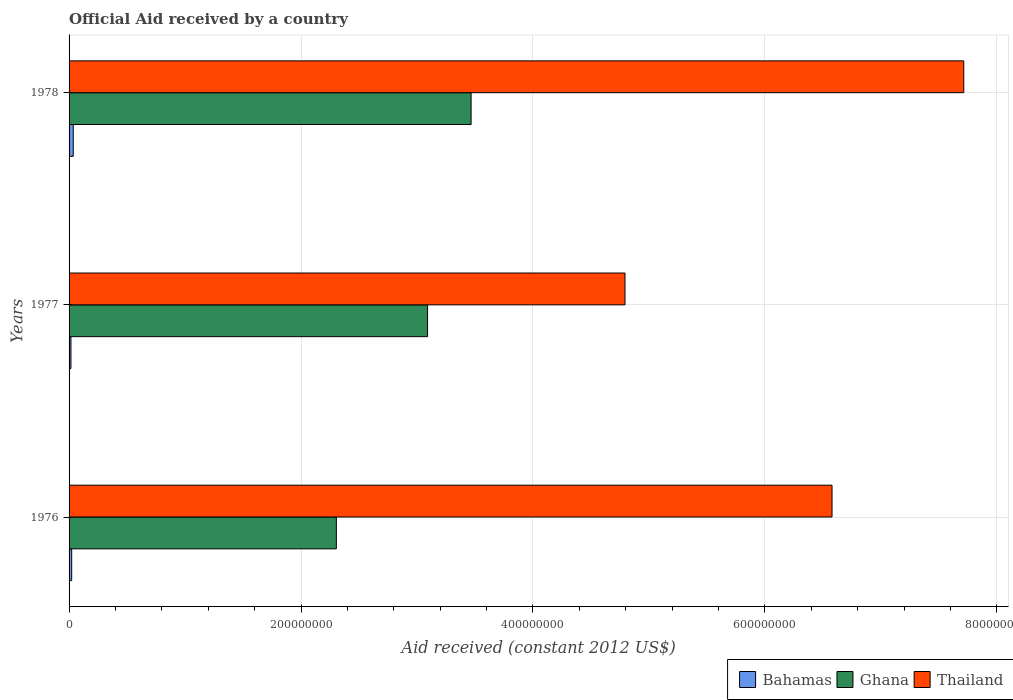How many groups of bars are there?
Ensure brevity in your answer.  3. Are the number of bars on each tick of the Y-axis equal?
Make the answer very short. Yes. In how many cases, is the number of bars for a given year not equal to the number of legend labels?
Offer a very short reply. 0. What is the net official aid received in Thailand in 1978?
Your answer should be compact. 7.71e+08. Across all years, what is the maximum net official aid received in Thailand?
Provide a short and direct response. 7.71e+08. Across all years, what is the minimum net official aid received in Thailand?
Ensure brevity in your answer.  4.79e+08. In which year was the net official aid received in Ghana maximum?
Offer a very short reply. 1978. In which year was the net official aid received in Thailand minimum?
Provide a succinct answer. 1977. What is the total net official aid received in Ghana in the graph?
Your answer should be very brief. 8.86e+08. What is the difference between the net official aid received in Bahamas in 1976 and that in 1978?
Provide a short and direct response. -1.35e+06. What is the difference between the net official aid received in Bahamas in 1978 and the net official aid received in Thailand in 1977?
Provide a short and direct response. -4.76e+08. What is the average net official aid received in Thailand per year?
Your response must be concise. 6.36e+08. In the year 1978, what is the difference between the net official aid received in Ghana and net official aid received in Thailand?
Ensure brevity in your answer.  -4.25e+08. What is the ratio of the net official aid received in Bahamas in 1977 to that in 1978?
Offer a very short reply. 0.45. Is the difference between the net official aid received in Ghana in 1976 and 1978 greater than the difference between the net official aid received in Thailand in 1976 and 1978?
Offer a terse response. No. What is the difference between the highest and the second highest net official aid received in Thailand?
Make the answer very short. 1.14e+08. What is the difference between the highest and the lowest net official aid received in Thailand?
Your answer should be compact. 2.92e+08. In how many years, is the net official aid received in Ghana greater than the average net official aid received in Ghana taken over all years?
Offer a very short reply. 2. Is the sum of the net official aid received in Thailand in 1977 and 1978 greater than the maximum net official aid received in Ghana across all years?
Ensure brevity in your answer.  Yes. What does the 1st bar from the top in 1978 represents?
Give a very brief answer. Thailand. What does the 3rd bar from the bottom in 1976 represents?
Provide a short and direct response. Thailand. Is it the case that in every year, the sum of the net official aid received in Bahamas and net official aid received in Ghana is greater than the net official aid received in Thailand?
Provide a succinct answer. No. How many years are there in the graph?
Offer a very short reply. 3. What is the difference between two consecutive major ticks on the X-axis?
Make the answer very short. 2.00e+08. Does the graph contain any zero values?
Offer a terse response. No. How many legend labels are there?
Make the answer very short. 3. What is the title of the graph?
Your response must be concise. Official Aid received by a country. Does "Solomon Islands" appear as one of the legend labels in the graph?
Make the answer very short. No. What is the label or title of the X-axis?
Your answer should be very brief. Aid received (constant 2012 US$). What is the Aid received (constant 2012 US$) of Bahamas in 1976?
Give a very brief answer. 2.25e+06. What is the Aid received (constant 2012 US$) in Ghana in 1976?
Your answer should be very brief. 2.30e+08. What is the Aid received (constant 2012 US$) of Thailand in 1976?
Provide a succinct answer. 6.58e+08. What is the Aid received (constant 2012 US$) of Bahamas in 1977?
Give a very brief answer. 1.62e+06. What is the Aid received (constant 2012 US$) of Ghana in 1977?
Your answer should be compact. 3.09e+08. What is the Aid received (constant 2012 US$) in Thailand in 1977?
Keep it short and to the point. 4.79e+08. What is the Aid received (constant 2012 US$) of Bahamas in 1978?
Offer a very short reply. 3.60e+06. What is the Aid received (constant 2012 US$) in Ghana in 1978?
Give a very brief answer. 3.47e+08. What is the Aid received (constant 2012 US$) of Thailand in 1978?
Give a very brief answer. 7.71e+08. Across all years, what is the maximum Aid received (constant 2012 US$) of Bahamas?
Provide a succinct answer. 3.60e+06. Across all years, what is the maximum Aid received (constant 2012 US$) in Ghana?
Your answer should be compact. 3.47e+08. Across all years, what is the maximum Aid received (constant 2012 US$) in Thailand?
Make the answer very short. 7.71e+08. Across all years, what is the minimum Aid received (constant 2012 US$) of Bahamas?
Your answer should be very brief. 1.62e+06. Across all years, what is the minimum Aid received (constant 2012 US$) in Ghana?
Make the answer very short. 2.30e+08. Across all years, what is the minimum Aid received (constant 2012 US$) in Thailand?
Offer a very short reply. 4.79e+08. What is the total Aid received (constant 2012 US$) of Bahamas in the graph?
Ensure brevity in your answer.  7.47e+06. What is the total Aid received (constant 2012 US$) in Ghana in the graph?
Offer a very short reply. 8.86e+08. What is the total Aid received (constant 2012 US$) in Thailand in the graph?
Your answer should be very brief. 1.91e+09. What is the difference between the Aid received (constant 2012 US$) in Bahamas in 1976 and that in 1977?
Offer a terse response. 6.30e+05. What is the difference between the Aid received (constant 2012 US$) in Ghana in 1976 and that in 1977?
Make the answer very short. -7.86e+07. What is the difference between the Aid received (constant 2012 US$) in Thailand in 1976 and that in 1977?
Give a very brief answer. 1.79e+08. What is the difference between the Aid received (constant 2012 US$) of Bahamas in 1976 and that in 1978?
Ensure brevity in your answer.  -1.35e+06. What is the difference between the Aid received (constant 2012 US$) in Ghana in 1976 and that in 1978?
Your response must be concise. -1.16e+08. What is the difference between the Aid received (constant 2012 US$) in Thailand in 1976 and that in 1978?
Provide a short and direct response. -1.14e+08. What is the difference between the Aid received (constant 2012 US$) in Bahamas in 1977 and that in 1978?
Keep it short and to the point. -1.98e+06. What is the difference between the Aid received (constant 2012 US$) of Ghana in 1977 and that in 1978?
Offer a very short reply. -3.75e+07. What is the difference between the Aid received (constant 2012 US$) in Thailand in 1977 and that in 1978?
Offer a terse response. -2.92e+08. What is the difference between the Aid received (constant 2012 US$) of Bahamas in 1976 and the Aid received (constant 2012 US$) of Ghana in 1977?
Provide a succinct answer. -3.07e+08. What is the difference between the Aid received (constant 2012 US$) of Bahamas in 1976 and the Aid received (constant 2012 US$) of Thailand in 1977?
Provide a short and direct response. -4.77e+08. What is the difference between the Aid received (constant 2012 US$) in Ghana in 1976 and the Aid received (constant 2012 US$) in Thailand in 1977?
Keep it short and to the point. -2.49e+08. What is the difference between the Aid received (constant 2012 US$) in Bahamas in 1976 and the Aid received (constant 2012 US$) in Ghana in 1978?
Offer a terse response. -3.44e+08. What is the difference between the Aid received (constant 2012 US$) of Bahamas in 1976 and the Aid received (constant 2012 US$) of Thailand in 1978?
Give a very brief answer. -7.69e+08. What is the difference between the Aid received (constant 2012 US$) in Ghana in 1976 and the Aid received (constant 2012 US$) in Thailand in 1978?
Ensure brevity in your answer.  -5.41e+08. What is the difference between the Aid received (constant 2012 US$) of Bahamas in 1977 and the Aid received (constant 2012 US$) of Ghana in 1978?
Make the answer very short. -3.45e+08. What is the difference between the Aid received (constant 2012 US$) of Bahamas in 1977 and the Aid received (constant 2012 US$) of Thailand in 1978?
Keep it short and to the point. -7.70e+08. What is the difference between the Aid received (constant 2012 US$) in Ghana in 1977 and the Aid received (constant 2012 US$) in Thailand in 1978?
Your response must be concise. -4.62e+08. What is the average Aid received (constant 2012 US$) in Bahamas per year?
Your response must be concise. 2.49e+06. What is the average Aid received (constant 2012 US$) in Ghana per year?
Your answer should be compact. 2.95e+08. What is the average Aid received (constant 2012 US$) of Thailand per year?
Your answer should be compact. 6.36e+08. In the year 1976, what is the difference between the Aid received (constant 2012 US$) in Bahamas and Aid received (constant 2012 US$) in Ghana?
Your answer should be compact. -2.28e+08. In the year 1976, what is the difference between the Aid received (constant 2012 US$) in Bahamas and Aid received (constant 2012 US$) in Thailand?
Your response must be concise. -6.56e+08. In the year 1976, what is the difference between the Aid received (constant 2012 US$) of Ghana and Aid received (constant 2012 US$) of Thailand?
Make the answer very short. -4.27e+08. In the year 1977, what is the difference between the Aid received (constant 2012 US$) in Bahamas and Aid received (constant 2012 US$) in Ghana?
Provide a succinct answer. -3.07e+08. In the year 1977, what is the difference between the Aid received (constant 2012 US$) of Bahamas and Aid received (constant 2012 US$) of Thailand?
Provide a short and direct response. -4.78e+08. In the year 1977, what is the difference between the Aid received (constant 2012 US$) of Ghana and Aid received (constant 2012 US$) of Thailand?
Offer a very short reply. -1.70e+08. In the year 1978, what is the difference between the Aid received (constant 2012 US$) of Bahamas and Aid received (constant 2012 US$) of Ghana?
Make the answer very short. -3.43e+08. In the year 1978, what is the difference between the Aid received (constant 2012 US$) of Bahamas and Aid received (constant 2012 US$) of Thailand?
Give a very brief answer. -7.68e+08. In the year 1978, what is the difference between the Aid received (constant 2012 US$) in Ghana and Aid received (constant 2012 US$) in Thailand?
Provide a succinct answer. -4.25e+08. What is the ratio of the Aid received (constant 2012 US$) in Bahamas in 1976 to that in 1977?
Make the answer very short. 1.39. What is the ratio of the Aid received (constant 2012 US$) in Ghana in 1976 to that in 1977?
Provide a short and direct response. 0.75. What is the ratio of the Aid received (constant 2012 US$) of Thailand in 1976 to that in 1977?
Your response must be concise. 1.37. What is the ratio of the Aid received (constant 2012 US$) in Bahamas in 1976 to that in 1978?
Keep it short and to the point. 0.62. What is the ratio of the Aid received (constant 2012 US$) in Ghana in 1976 to that in 1978?
Your answer should be compact. 0.66. What is the ratio of the Aid received (constant 2012 US$) in Thailand in 1976 to that in 1978?
Provide a short and direct response. 0.85. What is the ratio of the Aid received (constant 2012 US$) of Bahamas in 1977 to that in 1978?
Your response must be concise. 0.45. What is the ratio of the Aid received (constant 2012 US$) in Ghana in 1977 to that in 1978?
Offer a very short reply. 0.89. What is the ratio of the Aid received (constant 2012 US$) of Thailand in 1977 to that in 1978?
Your response must be concise. 0.62. What is the difference between the highest and the second highest Aid received (constant 2012 US$) in Bahamas?
Keep it short and to the point. 1.35e+06. What is the difference between the highest and the second highest Aid received (constant 2012 US$) of Ghana?
Offer a very short reply. 3.75e+07. What is the difference between the highest and the second highest Aid received (constant 2012 US$) in Thailand?
Provide a succinct answer. 1.14e+08. What is the difference between the highest and the lowest Aid received (constant 2012 US$) in Bahamas?
Make the answer very short. 1.98e+06. What is the difference between the highest and the lowest Aid received (constant 2012 US$) in Ghana?
Ensure brevity in your answer.  1.16e+08. What is the difference between the highest and the lowest Aid received (constant 2012 US$) of Thailand?
Provide a short and direct response. 2.92e+08. 